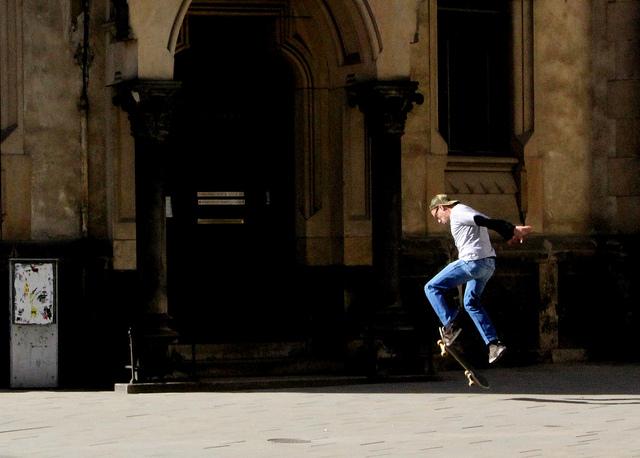What is the man playing?
Write a very short answer. Skateboarding. What is the building made of?
Be succinct. Concrete. Are there flowers behind the man?
Concise answer only. No. Is there any shadow touching the body of the male in this picture?
Keep it brief. No. What is the man doing?
Write a very short answer. Skateboarding. How old is this man?
Answer briefly. 20. Is his cap on backwards?
Keep it brief. Yes. 